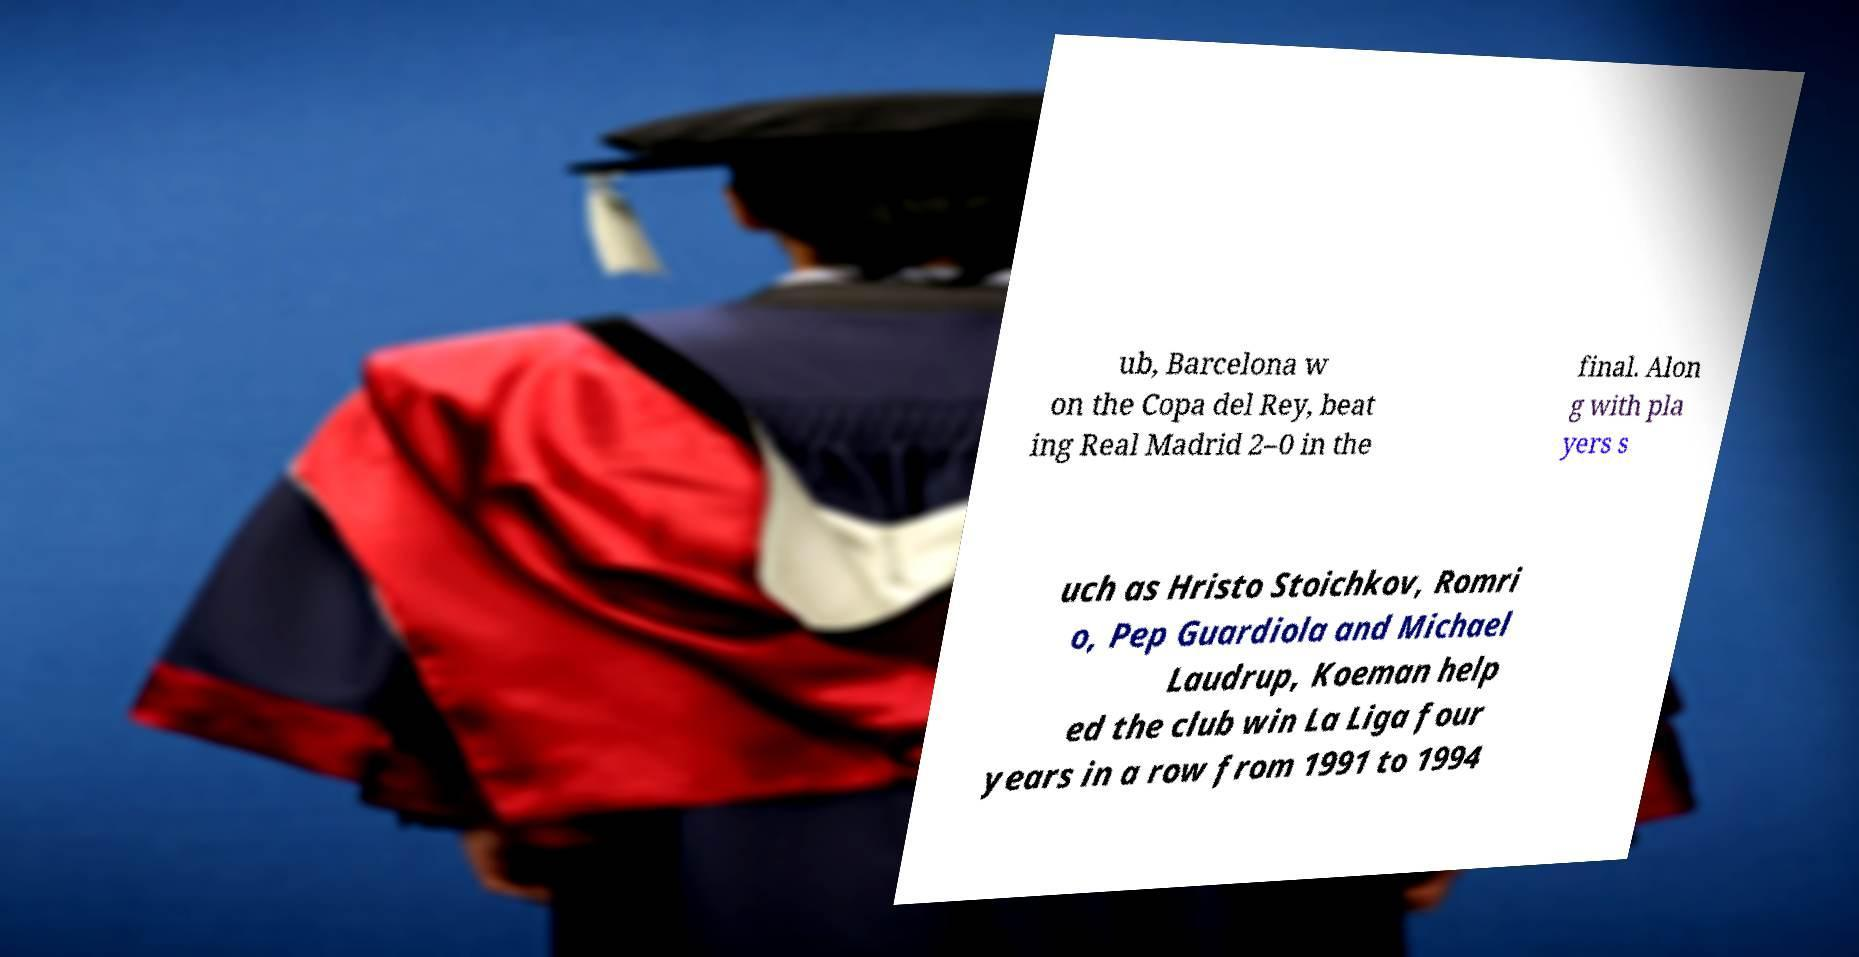Please read and relay the text visible in this image. What does it say? ub, Barcelona w on the Copa del Rey, beat ing Real Madrid 2–0 in the final. Alon g with pla yers s uch as Hristo Stoichkov, Romri o, Pep Guardiola and Michael Laudrup, Koeman help ed the club win La Liga four years in a row from 1991 to 1994 